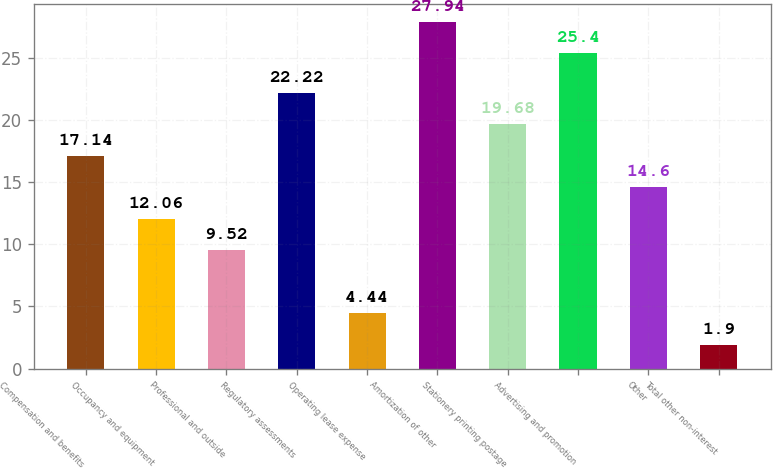Convert chart. <chart><loc_0><loc_0><loc_500><loc_500><bar_chart><fcel>Compensation and benefits<fcel>Occupancy and equipment<fcel>Professional and outside<fcel>Regulatory assessments<fcel>Operating lease expense<fcel>Amortization of other<fcel>Stationery printing postage<fcel>Advertising and promotion<fcel>Other<fcel>Total other non-interest<nl><fcel>17.14<fcel>12.06<fcel>9.52<fcel>22.22<fcel>4.44<fcel>27.94<fcel>19.68<fcel>25.4<fcel>14.6<fcel>1.9<nl></chart> 